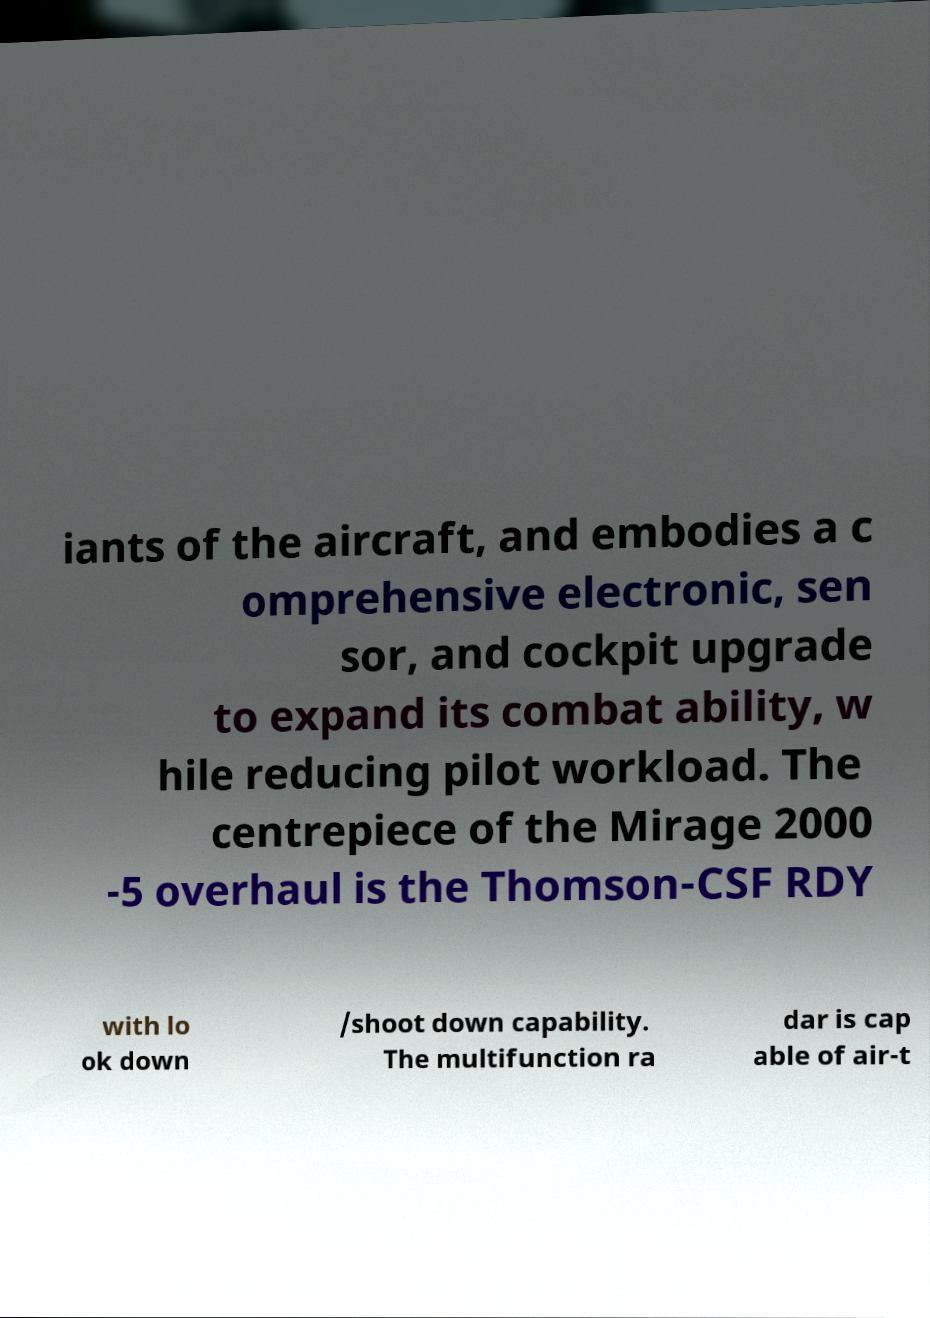For documentation purposes, I need the text within this image transcribed. Could you provide that? iants of the aircraft, and embodies a c omprehensive electronic, sen sor, and cockpit upgrade to expand its combat ability, w hile reducing pilot workload. The centrepiece of the Mirage 2000 -5 overhaul is the Thomson-CSF RDY with lo ok down /shoot down capability. The multifunction ra dar is cap able of air-t 